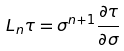Convert formula to latex. <formula><loc_0><loc_0><loc_500><loc_500>L _ { n } \tau = \sigma ^ { n + 1 } \frac { \partial \tau } { \partial \sigma }</formula> 